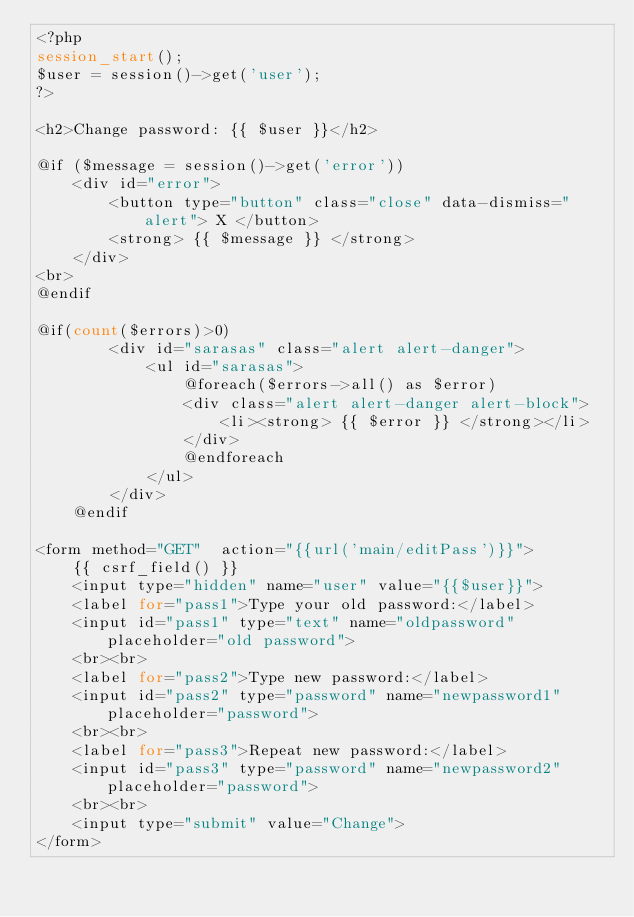Convert code to text. <code><loc_0><loc_0><loc_500><loc_500><_PHP_><?php
session_start();
$user = session()->get('user');
?>

<h2>Change password: {{ $user }}</h2>

@if ($message = session()->get('error'))
    <div id="error">
        <button type="button" class="close" data-dismiss="alert"> X </button>
        <strong> {{ $message }} </strong>
    </div>
<br>
@endif

@if(count($errors)>0)
        <div id="sarasas" class="alert alert-danger">
            <ul id="sarasas">
                @foreach($errors->all() as $error)
                <div class="alert alert-danger alert-block">
                    <li><strong> {{ $error }} </strong></li>
                </div>
                @endforeach
            </ul>    
        </div>
    @endif

<form method="GET"  action="{{url('main/editPass')}}"> 
    {{ csrf_field() }}
    <input type="hidden" name="user" value="{{$user}}">
    <label for="pass1">Type your old password:</label>
    <input id="pass1" type="text" name="oldpassword" placeholder="old password">
    <br><br>
    <label for="pass2">Type new password:</label>
    <input id="pass2" type="password" name="newpassword1" placeholder="password">
    <br><br>
    <label for="pass3">Repeat new password:</label>
    <input id="pass3" type="password" name="newpassword2" placeholder="password">
    <br><br>
    <input type="submit" value="Change">
</form></code> 